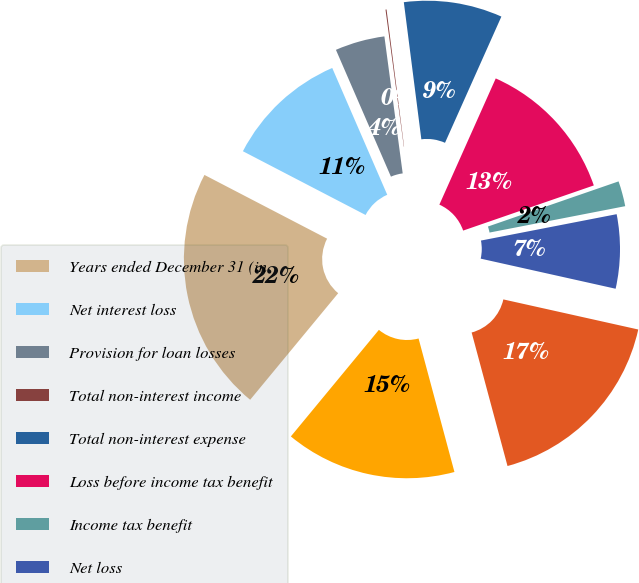<chart> <loc_0><loc_0><loc_500><loc_500><pie_chart><fcel>Years ended December 31 (in<fcel>Net interest loss<fcel>Provision for loan losses<fcel>Total non-interest income<fcel>Total non-interest expense<fcel>Loss before income tax benefit<fcel>Income tax benefit<fcel>Net loss<fcel>Average total assets<fcel>Average total liabilities<nl><fcel>21.64%<fcel>10.86%<fcel>4.4%<fcel>0.09%<fcel>8.71%<fcel>13.02%<fcel>2.24%<fcel>6.55%<fcel>17.33%<fcel>15.17%<nl></chart> 